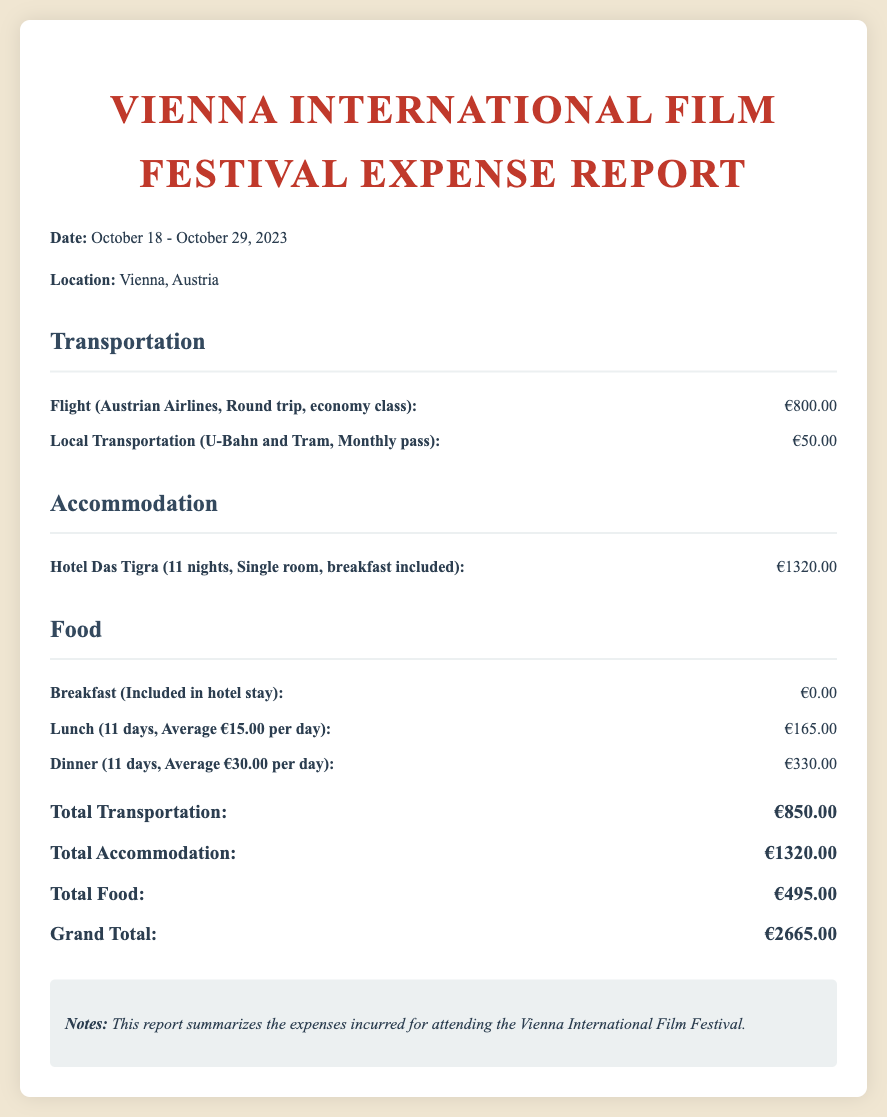What are the trip dates? The trip dates are specified in the document as October 18 - October 29, 2023.
Answer: October 18 - October 29, 2023 What is the total transportation cost? The total transportation cost is the sum of the flight and local transportation costs, which is €800.00 + €50.00 = €850.00.
Answer: €850.00 How many nights did the accommodation last? The document states that the accommodation lasted for 11 nights at Hotel Das Tigra.
Answer: 11 nights What is the average cost of lunch per day? The average cost for lunch over 11 days is indicated as €15.00 per day.
Answer: €15.00 What is the grand total of all expenses? The grand total is the sum of all categories listed, which amounts to €2665.00.
Answer: €2665.00 How much was spent on dinner? The document specifies that the total cost for dinner over 11 days amounts to €330.00.
Answer: €330.00 Is breakfast included in the food costs? The expense report indicates that breakfast is included in the hotel stay, thus costing €0.00.
Answer: €0.00 What type of flight was booked? The flight is identified as a round trip on Austrian Airlines in economy class.
Answer: Round trip, economy class What is the name of the hotel where accommodation was provided? The hotel where accommodation was provided is called Hotel Das Tigra.
Answer: Hotel Das Tigra 